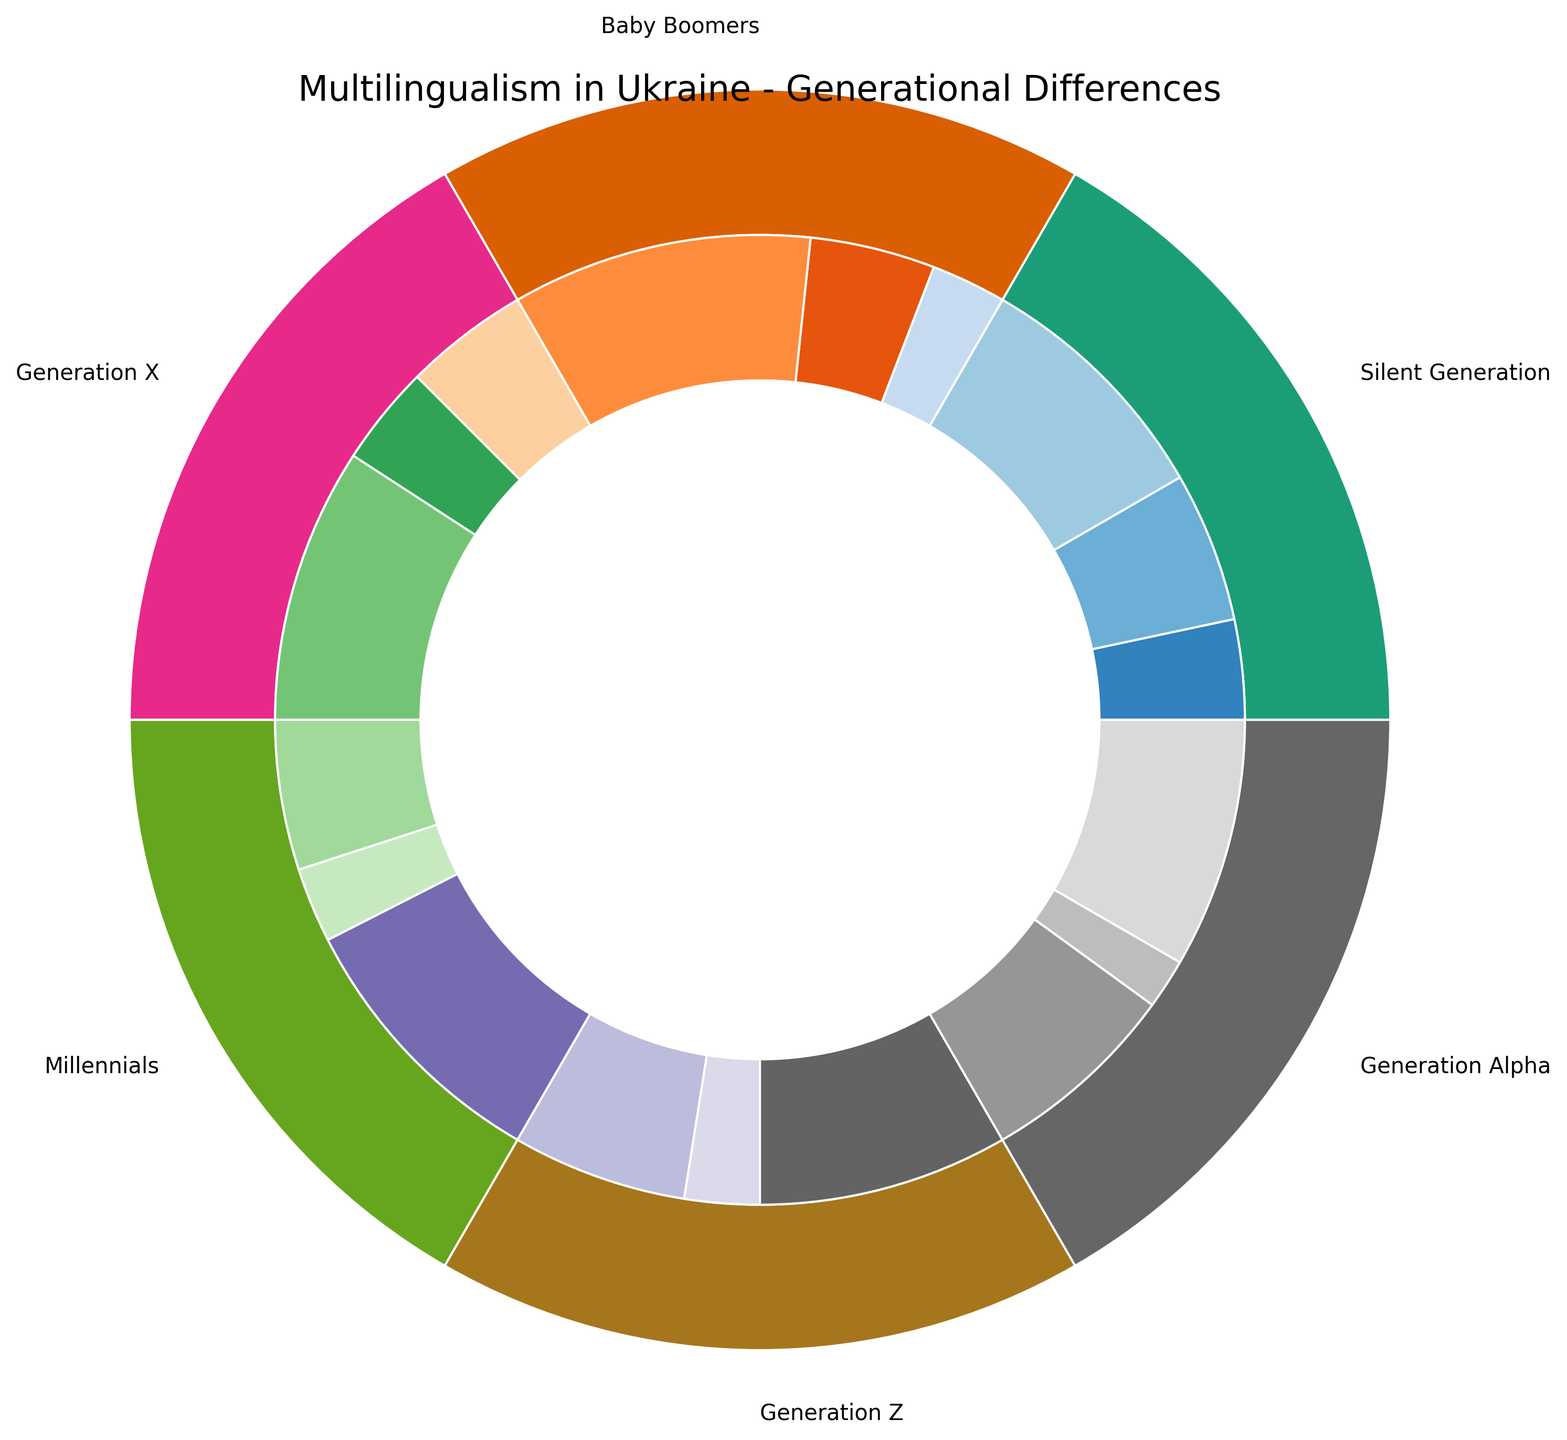What generation has the highest percentage of Monolingual Ukrainian speakers? Look at the innermost ring for each segment labeled with generations, identify the wavelength corresponding to Monolingual Ukrainian and find the largest segment
Answer: Generation Alpha Which generation has the smallest proportion of Monolingual Russian speakers compared to Monolingual Ukrainian speakers? Compare the lengths of the innermost ring segments for Monolingual Russian and Monolingual Ukrainian for all generations. Identify the generation where the Monolingual Russian segment is smallest in comparison to Monolingual Ukrainian segment
Answer: Generation Alpha How does the percentage of Monolingual Russian speakers change from Silent Generation to Generation Alpha? Note the percentage values for Monolingual Russian in Silent Generation (30%) and Generation Alpha (10%). Calculate the difference
Answer: Decreases by 20% Which two consecutive generations have the same percentage of Bilingual Ukrainian-Russian speakers, and what is the percentage? Identify the segments for Bilingual Ukrainian-Russian across all generations and find the two consecutive generations with identical segment lengths. Note the percentage value
Answer: Millennials and Generation Z, 55% What is the generational trend for Monolingual Ukrainian speakers from Silent Generation to Generation Alpha? Observe the segments for Monolingual Ukrainian from the outermost circle in sequence starting from Silent Generation to Generation Alpha. Describe the trend
Answer: Increases Compare the percentage of Monolingual Russian speakers in Baby Boomers and Generation X. Look at the innermost ring segments for Monolingual Russian in Baby Boomers (25%) and Generation X (20%). Compare these percentages
Answer: Baby Boomers has 5% more Which generation has the largest proportion of bilingual (Ukrainian-Russian) speakers? Identify the longest segment in the innermost ring marked as Bilingual Ukrainian-Russian. Note the corresponding generation
Answer: Baby Boomers What is the overall percentage of Monolingual Ukrainian speakers across all generations represented in the chart? Sum the percentages of Monolingual Ukrainian speakers from all generations: 20% (Silent Generation) + 15% (Baby Boomers) + 25% (Generation X) + 30% (Millennials) + 35% (Generation Z) + 40% (Generation Alpha)
Answer: 165% How does the percentage of bilingual speakers compare between Millennials and Generation X? Look at the innermost ring segments for Bilingual Ukrainian-Russian in Millennials and Generation X. Both are 55%, so they are equal
Answer: Equal When comparing Silent Generation and Generation Alpha, which has a higher percentage of speakers who speak both Ukrainian and Russian? Compare the innermost segments for Bilingual Ukrainian-Russian in Silent Generation (50%) and Generation Alpha (50%). Note that they are equal
Answer: Equal 